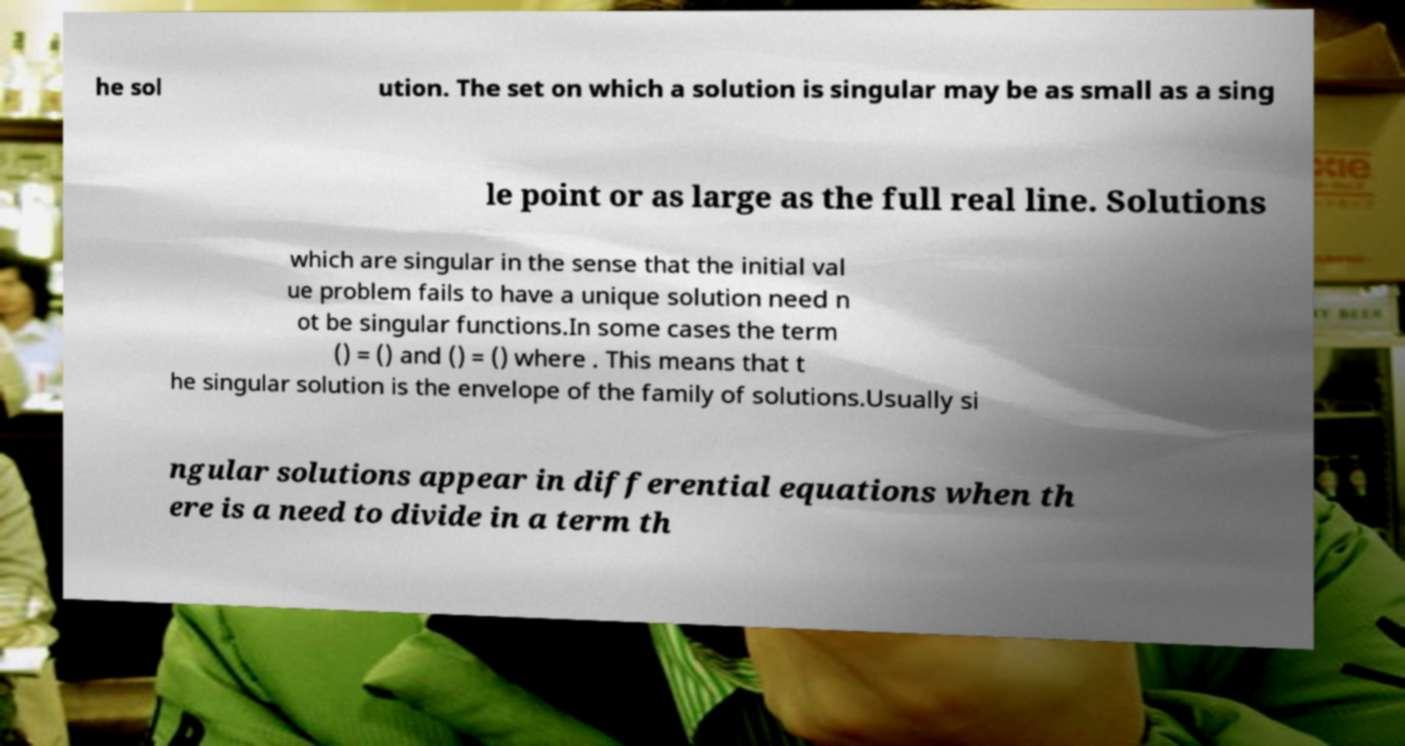There's text embedded in this image that I need extracted. Can you transcribe it verbatim? he sol ution. The set on which a solution is singular may be as small as a sing le point or as large as the full real line. Solutions which are singular in the sense that the initial val ue problem fails to have a unique solution need n ot be singular functions.In some cases the term () = () and () = () where . This means that t he singular solution is the envelope of the family of solutions.Usually si ngular solutions appear in differential equations when th ere is a need to divide in a term th 